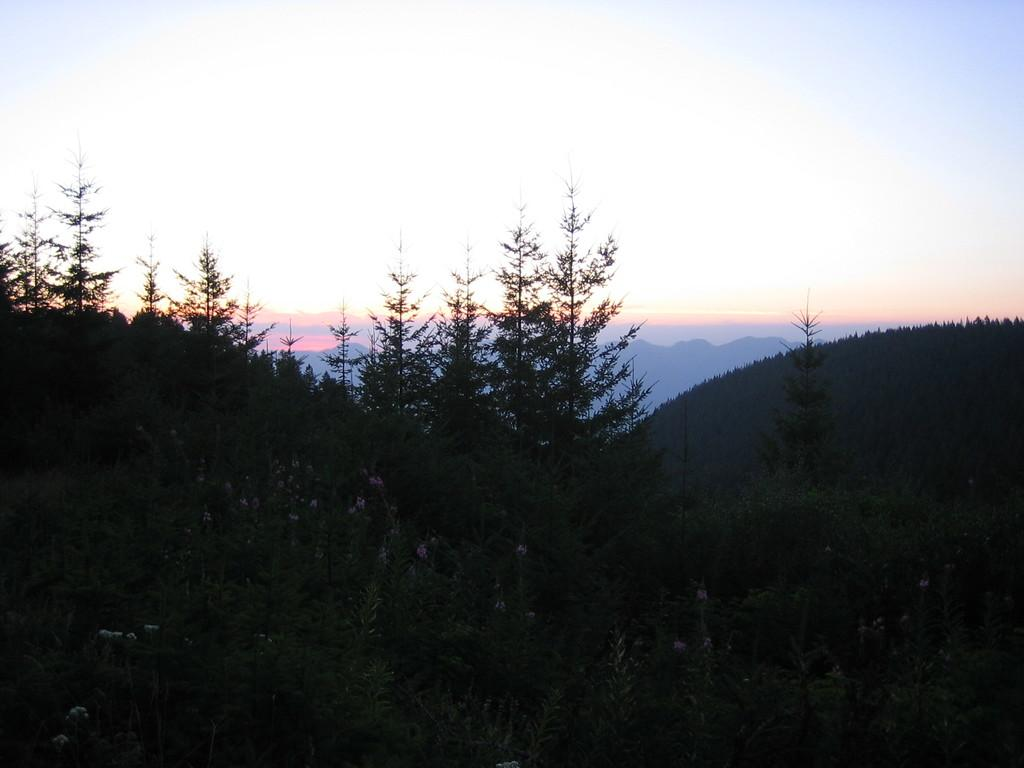What time of day was the image taken? The image was taken during the evening. What type of landscape can be seen in the image? There are hills in the image. What type of vegetation is present in the image? There are trees and plants in the image. What part of the natural environment is visible in the image? The sky is visible in the image. What type of sheet is draped over the secretary in the image? There is no secretary or sheet present in the image. 